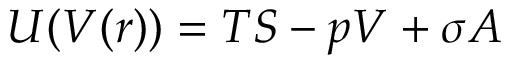Convert formula to latex. <formula><loc_0><loc_0><loc_500><loc_500>U ( V ( r ) ) = T S - p V + \sigma A</formula> 